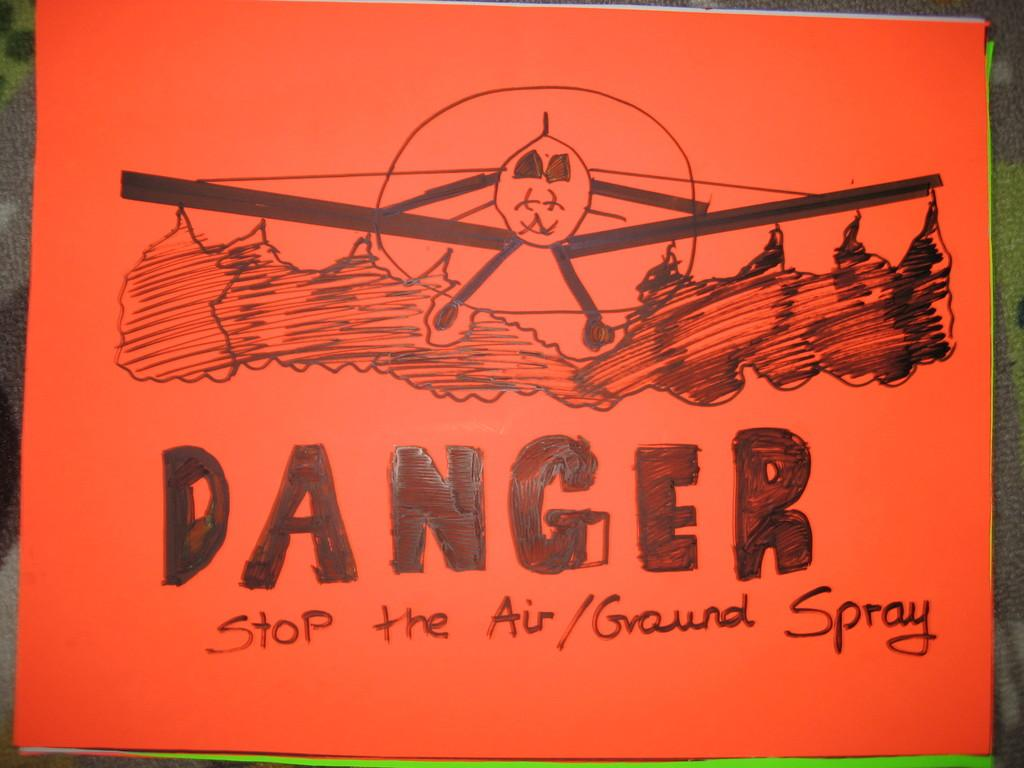<image>
Share a concise interpretation of the image provided. a red sign that reads danger stop the air/ground spray 